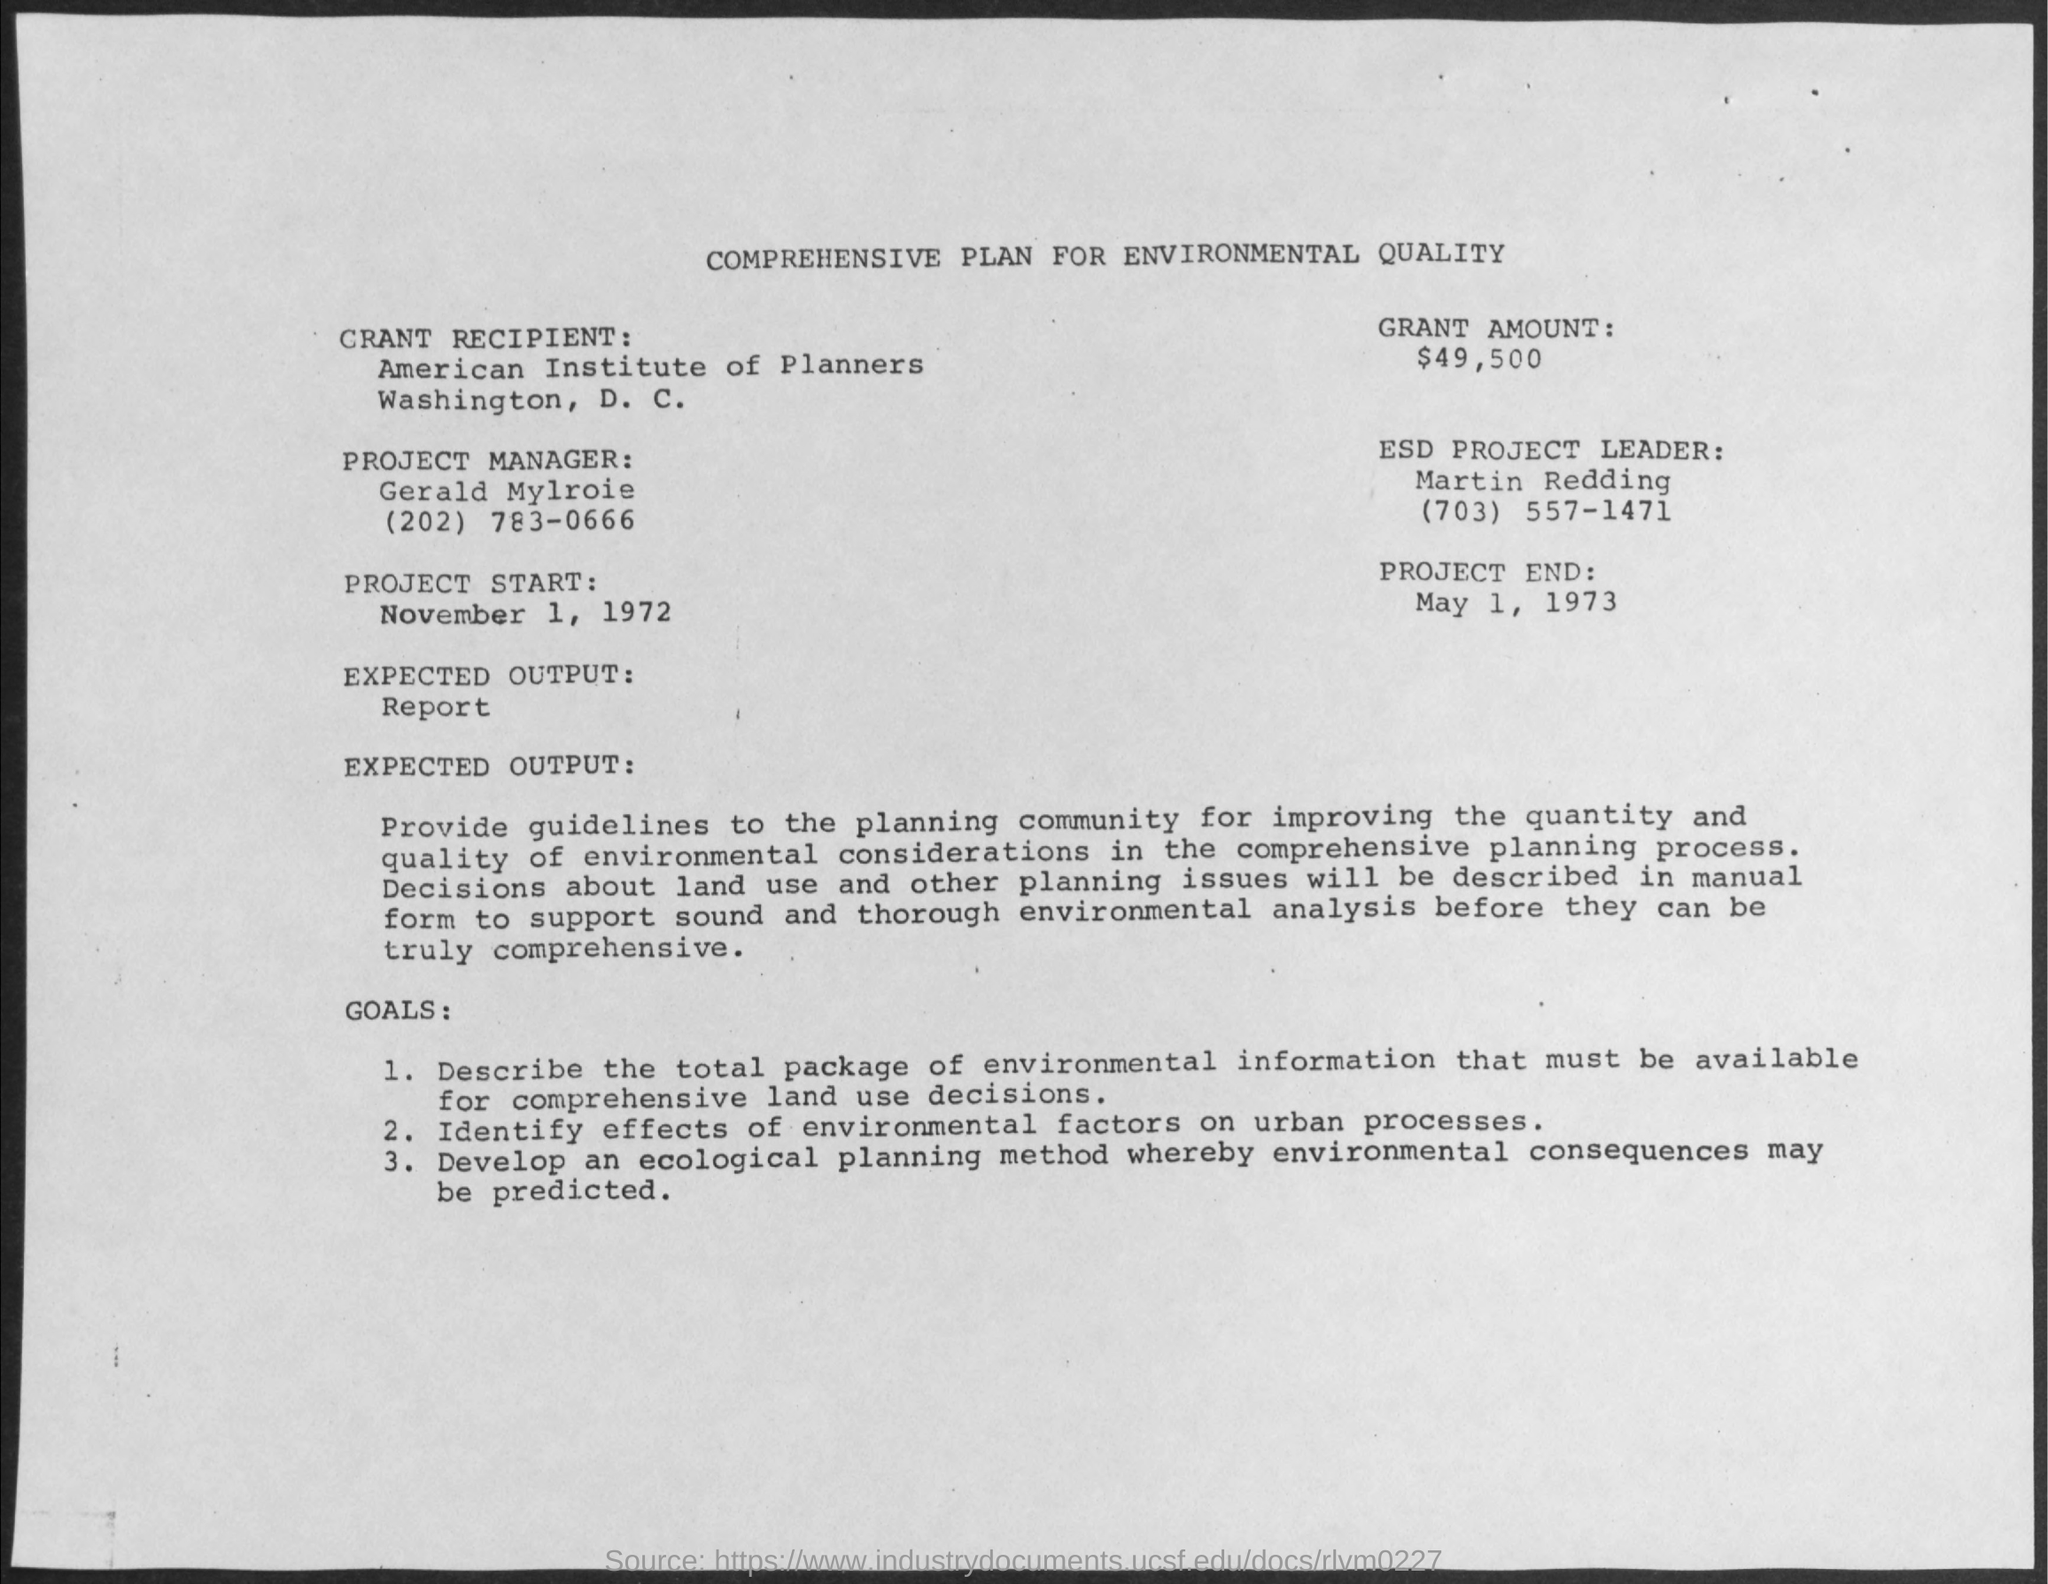List a handful of essential elements in this visual. The ESD project leader's name is Martin Redding. The grant amount mentioned in the given plan is $49,500. Gerald Mylroie is the name of the project manager mentioned in the plan. The date of project end is May 1, 1973. The recipient of the grant is the American Institute of Planners. 